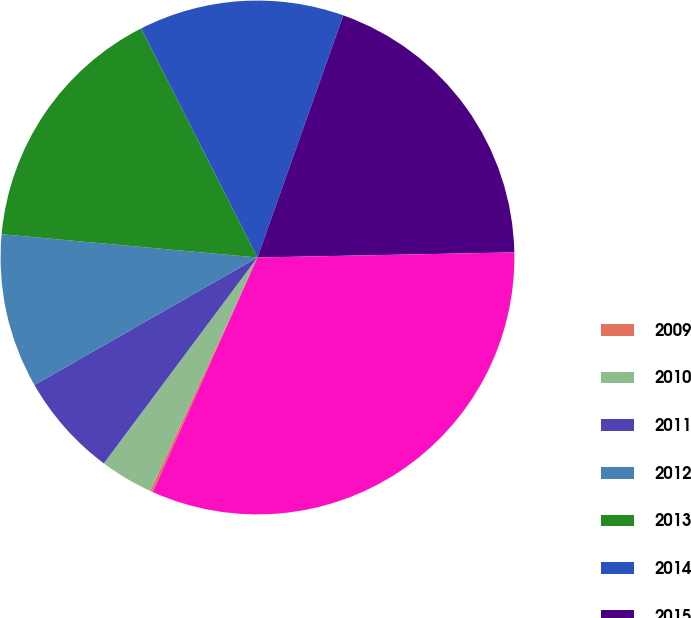Convert chart to OTSL. <chart><loc_0><loc_0><loc_500><loc_500><pie_chart><fcel>2009<fcel>2010<fcel>2011<fcel>2012<fcel>2013<fcel>2014<fcel>2015<fcel>Total<nl><fcel>0.17%<fcel>3.35%<fcel>6.53%<fcel>9.71%<fcel>16.08%<fcel>12.9%<fcel>19.26%<fcel>32.0%<nl></chart> 